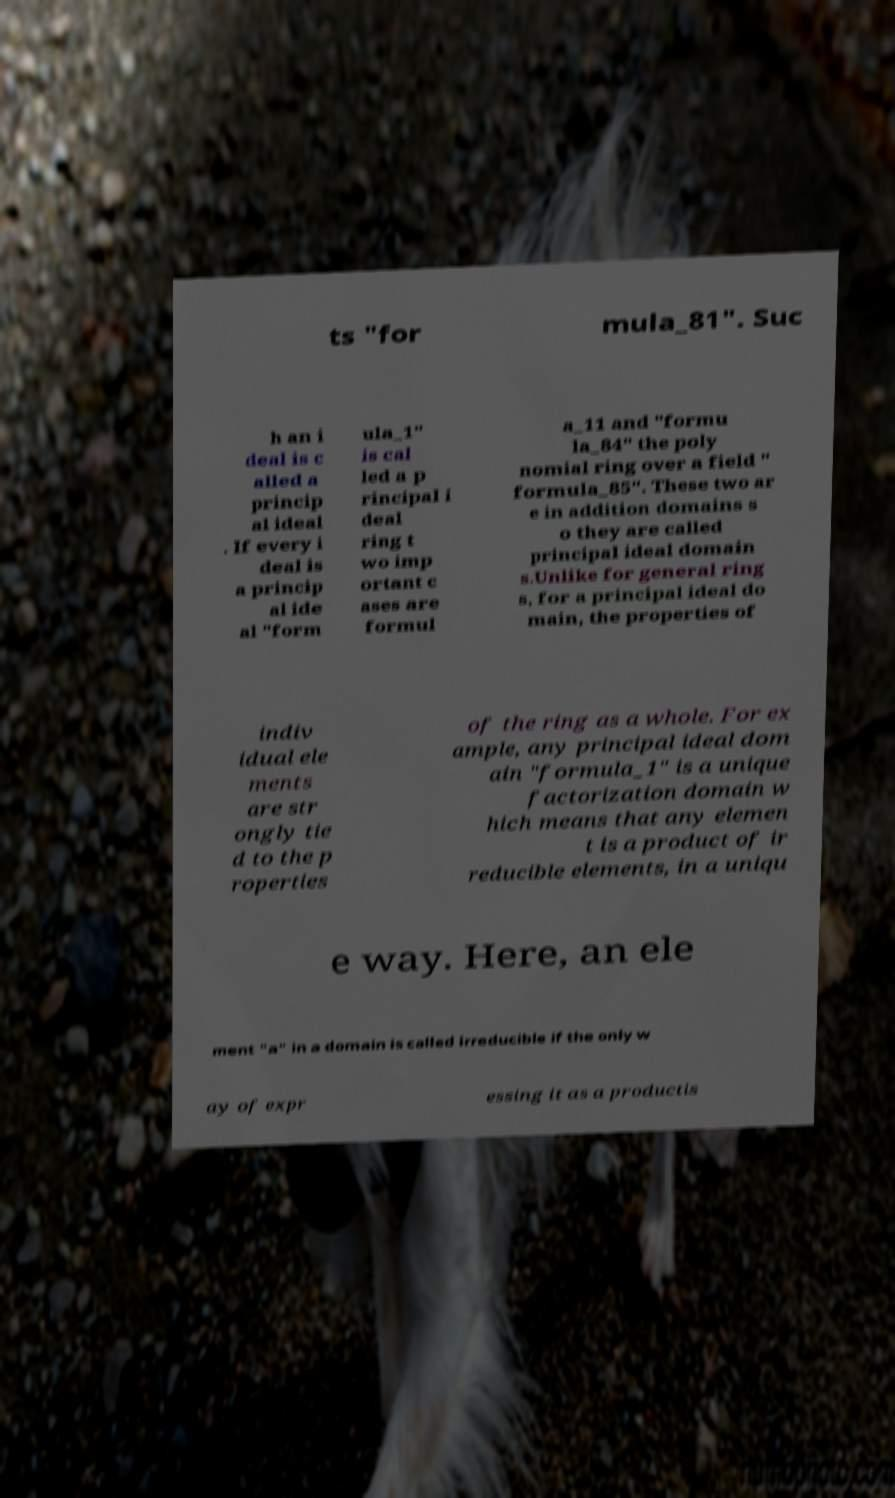Can you read and provide the text displayed in the image?This photo seems to have some interesting text. Can you extract and type it out for me? ts "for mula_81". Suc h an i deal is c alled a princip al ideal . If every i deal is a princip al ide al "form ula_1" is cal led a p rincipal i deal ring t wo imp ortant c ases are formul a_11 and "formu la_84" the poly nomial ring over a field " formula_85". These two ar e in addition domains s o they are called principal ideal domain s.Unlike for general ring s, for a principal ideal do main, the properties of indiv idual ele ments are str ongly tie d to the p roperties of the ring as a whole. For ex ample, any principal ideal dom ain "formula_1" is a unique factorization domain w hich means that any elemen t is a product of ir reducible elements, in a uniqu e way. Here, an ele ment "a" in a domain is called irreducible if the only w ay of expr essing it as a productis 